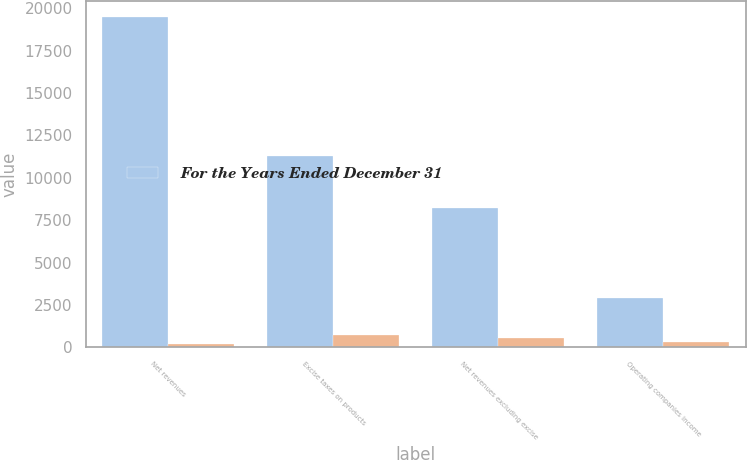Convert chart. <chart><loc_0><loc_0><loc_500><loc_500><stacked_bar_chart><ecel><fcel>Net revenues<fcel>Excise taxes on products<fcel>Net revenues excluding excise<fcel>Operating companies income<nl><fcel>For the Years Ended December 31<fcel>19469<fcel>11266<fcel>8203<fcel>2886<nl><fcel>nan<fcel>214<fcel>739<fcel>525<fcel>301<nl></chart> 